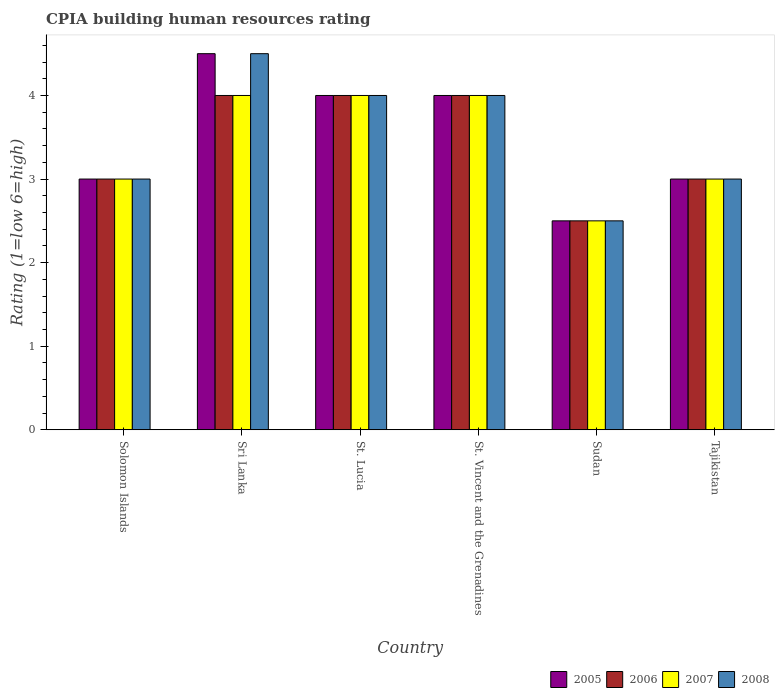How many different coloured bars are there?
Your answer should be very brief. 4. Are the number of bars per tick equal to the number of legend labels?
Make the answer very short. Yes. Are the number of bars on each tick of the X-axis equal?
Make the answer very short. Yes. How many bars are there on the 4th tick from the left?
Keep it short and to the point. 4. What is the label of the 2nd group of bars from the left?
Offer a very short reply. Sri Lanka. In which country was the CPIA rating in 2008 maximum?
Keep it short and to the point. Sri Lanka. In which country was the CPIA rating in 2006 minimum?
Offer a very short reply. Sudan. What is the average CPIA rating in 2008 per country?
Your answer should be very brief. 3.5. What is the difference between the CPIA rating of/in 2008 and CPIA rating of/in 2005 in Tajikistan?
Give a very brief answer. 0. In how many countries, is the CPIA rating in 2006 greater than 2.2?
Provide a succinct answer. 6. Is the difference between the CPIA rating in 2008 in Sudan and Tajikistan greater than the difference between the CPIA rating in 2005 in Sudan and Tajikistan?
Your response must be concise. No. What is the difference between the highest and the lowest CPIA rating in 2006?
Ensure brevity in your answer.  1.5. Is the sum of the CPIA rating in 2007 in St. Vincent and the Grenadines and Tajikistan greater than the maximum CPIA rating in 2008 across all countries?
Provide a short and direct response. Yes. What does the 2nd bar from the left in Solomon Islands represents?
Your response must be concise. 2006. What does the 2nd bar from the right in Sri Lanka represents?
Provide a short and direct response. 2007. How many bars are there?
Provide a succinct answer. 24. Are all the bars in the graph horizontal?
Provide a short and direct response. No. How many countries are there in the graph?
Offer a very short reply. 6. What is the difference between two consecutive major ticks on the Y-axis?
Ensure brevity in your answer.  1. Does the graph contain any zero values?
Give a very brief answer. No. Where does the legend appear in the graph?
Provide a succinct answer. Bottom right. How many legend labels are there?
Your answer should be very brief. 4. How are the legend labels stacked?
Your answer should be very brief. Horizontal. What is the title of the graph?
Provide a short and direct response. CPIA building human resources rating. What is the label or title of the Y-axis?
Your answer should be very brief. Rating (1=low 6=high). What is the Rating (1=low 6=high) of 2006 in Solomon Islands?
Your answer should be very brief. 3. What is the Rating (1=low 6=high) in 2005 in Sri Lanka?
Your response must be concise. 4.5. What is the Rating (1=low 6=high) of 2006 in Sri Lanka?
Make the answer very short. 4. What is the Rating (1=low 6=high) of 2008 in Sri Lanka?
Offer a very short reply. 4.5. What is the Rating (1=low 6=high) in 2005 in St. Lucia?
Your response must be concise. 4. What is the Rating (1=low 6=high) of 2006 in St. Lucia?
Keep it short and to the point. 4. What is the Rating (1=low 6=high) in 2008 in St. Lucia?
Ensure brevity in your answer.  4. What is the Rating (1=low 6=high) of 2006 in St. Vincent and the Grenadines?
Offer a terse response. 4. What is the Rating (1=low 6=high) of 2007 in St. Vincent and the Grenadines?
Your answer should be very brief. 4. What is the Rating (1=low 6=high) of 2008 in St. Vincent and the Grenadines?
Provide a short and direct response. 4. What is the Rating (1=low 6=high) in 2005 in Sudan?
Keep it short and to the point. 2.5. What is the Rating (1=low 6=high) of 2006 in Sudan?
Your answer should be compact. 2.5. What is the Rating (1=low 6=high) of 2007 in Sudan?
Offer a very short reply. 2.5. What is the Rating (1=low 6=high) of 2005 in Tajikistan?
Your response must be concise. 3. What is the Rating (1=low 6=high) in 2006 in Tajikistan?
Your answer should be compact. 3. What is the Rating (1=low 6=high) in 2007 in Tajikistan?
Provide a short and direct response. 3. Across all countries, what is the maximum Rating (1=low 6=high) in 2005?
Offer a very short reply. 4.5. Across all countries, what is the maximum Rating (1=low 6=high) of 2007?
Give a very brief answer. 4. Across all countries, what is the maximum Rating (1=low 6=high) of 2008?
Give a very brief answer. 4.5. Across all countries, what is the minimum Rating (1=low 6=high) of 2005?
Make the answer very short. 2.5. What is the total Rating (1=low 6=high) of 2005 in the graph?
Offer a very short reply. 21. What is the difference between the Rating (1=low 6=high) of 2006 in Solomon Islands and that in Sri Lanka?
Your answer should be very brief. -1. What is the difference between the Rating (1=low 6=high) of 2008 in Solomon Islands and that in Sri Lanka?
Offer a terse response. -1.5. What is the difference between the Rating (1=low 6=high) in 2005 in Solomon Islands and that in St. Lucia?
Offer a very short reply. -1. What is the difference between the Rating (1=low 6=high) in 2006 in Solomon Islands and that in St. Lucia?
Ensure brevity in your answer.  -1. What is the difference between the Rating (1=low 6=high) of 2007 in Solomon Islands and that in St. Lucia?
Your answer should be very brief. -1. What is the difference between the Rating (1=low 6=high) of 2008 in Solomon Islands and that in St. Vincent and the Grenadines?
Ensure brevity in your answer.  -1. What is the difference between the Rating (1=low 6=high) of 2007 in Solomon Islands and that in Sudan?
Keep it short and to the point. 0.5. What is the difference between the Rating (1=low 6=high) in 2006 in Sri Lanka and that in St. Lucia?
Your answer should be very brief. 0. What is the difference between the Rating (1=low 6=high) of 2007 in Sri Lanka and that in St. Lucia?
Your response must be concise. 0. What is the difference between the Rating (1=low 6=high) of 2008 in Sri Lanka and that in St. Lucia?
Ensure brevity in your answer.  0.5. What is the difference between the Rating (1=low 6=high) of 2005 in Sri Lanka and that in St. Vincent and the Grenadines?
Make the answer very short. 0.5. What is the difference between the Rating (1=low 6=high) of 2006 in Sri Lanka and that in St. Vincent and the Grenadines?
Your answer should be compact. 0. What is the difference between the Rating (1=low 6=high) in 2007 in Sri Lanka and that in St. Vincent and the Grenadines?
Your answer should be very brief. 0. What is the difference between the Rating (1=low 6=high) in 2008 in Sri Lanka and that in St. Vincent and the Grenadines?
Offer a very short reply. 0.5. What is the difference between the Rating (1=low 6=high) of 2006 in Sri Lanka and that in Tajikistan?
Give a very brief answer. 1. What is the difference between the Rating (1=low 6=high) of 2008 in Sri Lanka and that in Tajikistan?
Your answer should be compact. 1.5. What is the difference between the Rating (1=low 6=high) in 2006 in St. Lucia and that in St. Vincent and the Grenadines?
Your answer should be compact. 0. What is the difference between the Rating (1=low 6=high) of 2005 in St. Lucia and that in Sudan?
Your response must be concise. 1.5. What is the difference between the Rating (1=low 6=high) in 2005 in St. Lucia and that in Tajikistan?
Provide a succinct answer. 1. What is the difference between the Rating (1=low 6=high) of 2005 in St. Vincent and the Grenadines and that in Sudan?
Provide a succinct answer. 1.5. What is the difference between the Rating (1=low 6=high) in 2006 in St. Vincent and the Grenadines and that in Sudan?
Provide a short and direct response. 1.5. What is the difference between the Rating (1=low 6=high) in 2005 in St. Vincent and the Grenadines and that in Tajikistan?
Provide a succinct answer. 1. What is the difference between the Rating (1=low 6=high) in 2007 in St. Vincent and the Grenadines and that in Tajikistan?
Your answer should be very brief. 1. What is the difference between the Rating (1=low 6=high) of 2007 in Sudan and that in Tajikistan?
Make the answer very short. -0.5. What is the difference between the Rating (1=low 6=high) of 2005 in Solomon Islands and the Rating (1=low 6=high) of 2008 in Sri Lanka?
Give a very brief answer. -1.5. What is the difference between the Rating (1=low 6=high) in 2006 in Solomon Islands and the Rating (1=low 6=high) in 2008 in Sri Lanka?
Ensure brevity in your answer.  -1.5. What is the difference between the Rating (1=low 6=high) of 2006 in Solomon Islands and the Rating (1=low 6=high) of 2008 in St. Lucia?
Ensure brevity in your answer.  -1. What is the difference between the Rating (1=low 6=high) of 2007 in Solomon Islands and the Rating (1=low 6=high) of 2008 in St. Lucia?
Offer a very short reply. -1. What is the difference between the Rating (1=low 6=high) in 2005 in Solomon Islands and the Rating (1=low 6=high) in 2006 in St. Vincent and the Grenadines?
Make the answer very short. -1. What is the difference between the Rating (1=low 6=high) of 2006 in Solomon Islands and the Rating (1=low 6=high) of 2007 in St. Vincent and the Grenadines?
Your answer should be compact. -1. What is the difference between the Rating (1=low 6=high) in 2006 in Solomon Islands and the Rating (1=low 6=high) in 2008 in St. Vincent and the Grenadines?
Ensure brevity in your answer.  -1. What is the difference between the Rating (1=low 6=high) of 2007 in Solomon Islands and the Rating (1=low 6=high) of 2008 in St. Vincent and the Grenadines?
Ensure brevity in your answer.  -1. What is the difference between the Rating (1=low 6=high) of 2005 in Solomon Islands and the Rating (1=low 6=high) of 2006 in Sudan?
Keep it short and to the point. 0.5. What is the difference between the Rating (1=low 6=high) of 2005 in Solomon Islands and the Rating (1=low 6=high) of 2008 in Sudan?
Offer a terse response. 0.5. What is the difference between the Rating (1=low 6=high) in 2006 in Solomon Islands and the Rating (1=low 6=high) in 2007 in Sudan?
Provide a short and direct response. 0.5. What is the difference between the Rating (1=low 6=high) in 2006 in Solomon Islands and the Rating (1=low 6=high) in 2008 in Sudan?
Keep it short and to the point. 0.5. What is the difference between the Rating (1=low 6=high) in 2005 in Solomon Islands and the Rating (1=low 6=high) in 2007 in Tajikistan?
Your answer should be compact. 0. What is the difference between the Rating (1=low 6=high) of 2005 in Solomon Islands and the Rating (1=low 6=high) of 2008 in Tajikistan?
Provide a succinct answer. 0. What is the difference between the Rating (1=low 6=high) of 2006 in Solomon Islands and the Rating (1=low 6=high) of 2007 in Tajikistan?
Provide a succinct answer. 0. What is the difference between the Rating (1=low 6=high) of 2005 in Sri Lanka and the Rating (1=low 6=high) of 2006 in St. Lucia?
Ensure brevity in your answer.  0.5. What is the difference between the Rating (1=low 6=high) of 2005 in Sri Lanka and the Rating (1=low 6=high) of 2008 in St. Lucia?
Your answer should be compact. 0.5. What is the difference between the Rating (1=low 6=high) in 2005 in Sri Lanka and the Rating (1=low 6=high) in 2006 in St. Vincent and the Grenadines?
Offer a terse response. 0.5. What is the difference between the Rating (1=low 6=high) in 2005 in Sri Lanka and the Rating (1=low 6=high) in 2007 in St. Vincent and the Grenadines?
Give a very brief answer. 0.5. What is the difference between the Rating (1=low 6=high) of 2006 in Sri Lanka and the Rating (1=low 6=high) of 2008 in St. Vincent and the Grenadines?
Keep it short and to the point. 0. What is the difference between the Rating (1=low 6=high) of 2007 in Sri Lanka and the Rating (1=low 6=high) of 2008 in St. Vincent and the Grenadines?
Give a very brief answer. 0. What is the difference between the Rating (1=low 6=high) in 2005 in Sri Lanka and the Rating (1=low 6=high) in 2007 in Sudan?
Ensure brevity in your answer.  2. What is the difference between the Rating (1=low 6=high) of 2005 in Sri Lanka and the Rating (1=low 6=high) of 2008 in Sudan?
Your response must be concise. 2. What is the difference between the Rating (1=low 6=high) in 2006 in Sri Lanka and the Rating (1=low 6=high) in 2007 in Sudan?
Keep it short and to the point. 1.5. What is the difference between the Rating (1=low 6=high) of 2005 in Sri Lanka and the Rating (1=low 6=high) of 2007 in Tajikistan?
Make the answer very short. 1.5. What is the difference between the Rating (1=low 6=high) in 2006 in Sri Lanka and the Rating (1=low 6=high) in 2007 in Tajikistan?
Your response must be concise. 1. What is the difference between the Rating (1=low 6=high) of 2006 in Sri Lanka and the Rating (1=low 6=high) of 2008 in Tajikistan?
Make the answer very short. 1. What is the difference between the Rating (1=low 6=high) of 2007 in Sri Lanka and the Rating (1=low 6=high) of 2008 in Tajikistan?
Offer a very short reply. 1. What is the difference between the Rating (1=low 6=high) of 2005 in St. Lucia and the Rating (1=low 6=high) of 2006 in St. Vincent and the Grenadines?
Your answer should be compact. 0. What is the difference between the Rating (1=low 6=high) in 2005 in St. Lucia and the Rating (1=low 6=high) in 2008 in St. Vincent and the Grenadines?
Your answer should be very brief. 0. What is the difference between the Rating (1=low 6=high) in 2006 in St. Lucia and the Rating (1=low 6=high) in 2007 in St. Vincent and the Grenadines?
Keep it short and to the point. 0. What is the difference between the Rating (1=low 6=high) in 2006 in St. Lucia and the Rating (1=low 6=high) in 2008 in St. Vincent and the Grenadines?
Provide a short and direct response. 0. What is the difference between the Rating (1=low 6=high) of 2007 in St. Lucia and the Rating (1=low 6=high) of 2008 in St. Vincent and the Grenadines?
Your answer should be compact. 0. What is the difference between the Rating (1=low 6=high) in 2005 in St. Lucia and the Rating (1=low 6=high) in 2006 in Sudan?
Offer a terse response. 1.5. What is the difference between the Rating (1=low 6=high) of 2005 in St. Lucia and the Rating (1=low 6=high) of 2007 in Sudan?
Provide a short and direct response. 1.5. What is the difference between the Rating (1=low 6=high) of 2007 in St. Lucia and the Rating (1=low 6=high) of 2008 in Sudan?
Make the answer very short. 1.5. What is the difference between the Rating (1=low 6=high) in 2005 in St. Lucia and the Rating (1=low 6=high) in 2007 in Tajikistan?
Give a very brief answer. 1. What is the difference between the Rating (1=low 6=high) of 2006 in St. Lucia and the Rating (1=low 6=high) of 2008 in Tajikistan?
Keep it short and to the point. 1. What is the difference between the Rating (1=low 6=high) of 2005 in St. Vincent and the Grenadines and the Rating (1=low 6=high) of 2006 in Sudan?
Your answer should be very brief. 1.5. What is the difference between the Rating (1=low 6=high) of 2005 in St. Vincent and the Grenadines and the Rating (1=low 6=high) of 2008 in Sudan?
Offer a very short reply. 1.5. What is the difference between the Rating (1=low 6=high) in 2006 in St. Vincent and the Grenadines and the Rating (1=low 6=high) in 2007 in Sudan?
Your response must be concise. 1.5. What is the difference between the Rating (1=low 6=high) of 2005 in St. Vincent and the Grenadines and the Rating (1=low 6=high) of 2006 in Tajikistan?
Provide a short and direct response. 1. What is the difference between the Rating (1=low 6=high) in 2005 in St. Vincent and the Grenadines and the Rating (1=low 6=high) in 2008 in Tajikistan?
Offer a terse response. 1. What is the difference between the Rating (1=low 6=high) of 2006 in St. Vincent and the Grenadines and the Rating (1=low 6=high) of 2007 in Tajikistan?
Your response must be concise. 1. What is the difference between the Rating (1=low 6=high) of 2006 in Sudan and the Rating (1=low 6=high) of 2007 in Tajikistan?
Your response must be concise. -0.5. What is the difference between the Rating (1=low 6=high) of 2006 in Sudan and the Rating (1=low 6=high) of 2008 in Tajikistan?
Your response must be concise. -0.5. What is the average Rating (1=low 6=high) in 2005 per country?
Make the answer very short. 3.5. What is the average Rating (1=low 6=high) of 2006 per country?
Provide a succinct answer. 3.42. What is the average Rating (1=low 6=high) of 2007 per country?
Offer a very short reply. 3.42. What is the average Rating (1=low 6=high) in 2008 per country?
Offer a terse response. 3.5. What is the difference between the Rating (1=low 6=high) in 2005 and Rating (1=low 6=high) in 2006 in Solomon Islands?
Give a very brief answer. 0. What is the difference between the Rating (1=low 6=high) in 2005 and Rating (1=low 6=high) in 2007 in Solomon Islands?
Your answer should be very brief. 0. What is the difference between the Rating (1=low 6=high) of 2006 and Rating (1=low 6=high) of 2007 in Solomon Islands?
Offer a very short reply. 0. What is the difference between the Rating (1=low 6=high) in 2005 and Rating (1=low 6=high) in 2007 in Sri Lanka?
Ensure brevity in your answer.  0.5. What is the difference between the Rating (1=low 6=high) in 2005 and Rating (1=low 6=high) in 2008 in Sri Lanka?
Give a very brief answer. 0. What is the difference between the Rating (1=low 6=high) in 2007 and Rating (1=low 6=high) in 2008 in Sri Lanka?
Make the answer very short. -0.5. What is the difference between the Rating (1=low 6=high) of 2005 and Rating (1=low 6=high) of 2006 in St. Lucia?
Your response must be concise. 0. What is the difference between the Rating (1=low 6=high) in 2005 and Rating (1=low 6=high) in 2007 in St. Lucia?
Your answer should be very brief. 0. What is the difference between the Rating (1=low 6=high) of 2006 and Rating (1=low 6=high) of 2007 in St. Lucia?
Ensure brevity in your answer.  0. What is the difference between the Rating (1=low 6=high) in 2007 and Rating (1=low 6=high) in 2008 in St. Lucia?
Your answer should be compact. 0. What is the difference between the Rating (1=low 6=high) of 2005 and Rating (1=low 6=high) of 2006 in St. Vincent and the Grenadines?
Offer a terse response. 0. What is the difference between the Rating (1=low 6=high) of 2007 and Rating (1=low 6=high) of 2008 in St. Vincent and the Grenadines?
Your answer should be very brief. 0. What is the difference between the Rating (1=low 6=high) in 2005 and Rating (1=low 6=high) in 2007 in Sudan?
Offer a very short reply. 0. What is the difference between the Rating (1=low 6=high) of 2006 and Rating (1=low 6=high) of 2008 in Sudan?
Your response must be concise. 0. What is the difference between the Rating (1=low 6=high) in 2007 and Rating (1=low 6=high) in 2008 in Sudan?
Provide a short and direct response. 0. What is the difference between the Rating (1=low 6=high) in 2005 and Rating (1=low 6=high) in 2006 in Tajikistan?
Your response must be concise. 0. What is the difference between the Rating (1=low 6=high) in 2005 and Rating (1=low 6=high) in 2008 in Tajikistan?
Your answer should be compact. 0. What is the difference between the Rating (1=low 6=high) in 2006 and Rating (1=low 6=high) in 2007 in Tajikistan?
Your answer should be very brief. 0. What is the difference between the Rating (1=low 6=high) of 2007 and Rating (1=low 6=high) of 2008 in Tajikistan?
Offer a terse response. 0. What is the ratio of the Rating (1=low 6=high) of 2005 in Solomon Islands to that in Sri Lanka?
Provide a short and direct response. 0.67. What is the ratio of the Rating (1=low 6=high) of 2007 in Solomon Islands to that in Sri Lanka?
Make the answer very short. 0.75. What is the ratio of the Rating (1=low 6=high) in 2008 in Solomon Islands to that in Sri Lanka?
Offer a very short reply. 0.67. What is the ratio of the Rating (1=low 6=high) in 2006 in Solomon Islands to that in St. Lucia?
Provide a succinct answer. 0.75. What is the ratio of the Rating (1=low 6=high) of 2007 in Solomon Islands to that in St. Lucia?
Keep it short and to the point. 0.75. What is the ratio of the Rating (1=low 6=high) of 2005 in Solomon Islands to that in St. Vincent and the Grenadines?
Your answer should be very brief. 0.75. What is the ratio of the Rating (1=low 6=high) of 2008 in Solomon Islands to that in St. Vincent and the Grenadines?
Make the answer very short. 0.75. What is the ratio of the Rating (1=low 6=high) of 2007 in Solomon Islands to that in Sudan?
Your answer should be very brief. 1.2. What is the ratio of the Rating (1=low 6=high) in 2008 in Solomon Islands to that in Tajikistan?
Make the answer very short. 1. What is the ratio of the Rating (1=low 6=high) of 2005 in Sri Lanka to that in St. Lucia?
Make the answer very short. 1.12. What is the ratio of the Rating (1=low 6=high) of 2008 in Sri Lanka to that in St. Lucia?
Make the answer very short. 1.12. What is the ratio of the Rating (1=low 6=high) of 2005 in Sri Lanka to that in St. Vincent and the Grenadines?
Offer a very short reply. 1.12. What is the ratio of the Rating (1=low 6=high) of 2008 in Sri Lanka to that in St. Vincent and the Grenadines?
Offer a very short reply. 1.12. What is the ratio of the Rating (1=low 6=high) in 2007 in Sri Lanka to that in Sudan?
Provide a short and direct response. 1.6. What is the ratio of the Rating (1=low 6=high) in 2005 in Sri Lanka to that in Tajikistan?
Offer a very short reply. 1.5. What is the ratio of the Rating (1=low 6=high) in 2007 in Sri Lanka to that in Tajikistan?
Provide a short and direct response. 1.33. What is the ratio of the Rating (1=low 6=high) in 2007 in St. Lucia to that in St. Vincent and the Grenadines?
Provide a short and direct response. 1. What is the ratio of the Rating (1=low 6=high) of 2008 in St. Lucia to that in St. Vincent and the Grenadines?
Make the answer very short. 1. What is the ratio of the Rating (1=low 6=high) of 2007 in St. Lucia to that in Sudan?
Make the answer very short. 1.6. What is the ratio of the Rating (1=low 6=high) of 2008 in St. Lucia to that in Sudan?
Provide a short and direct response. 1.6. What is the ratio of the Rating (1=low 6=high) in 2005 in St. Lucia to that in Tajikistan?
Your answer should be very brief. 1.33. What is the ratio of the Rating (1=low 6=high) in 2006 in St. Lucia to that in Tajikistan?
Provide a short and direct response. 1.33. What is the ratio of the Rating (1=low 6=high) in 2007 in St. Lucia to that in Tajikistan?
Give a very brief answer. 1.33. What is the ratio of the Rating (1=low 6=high) in 2008 in St. Lucia to that in Tajikistan?
Your answer should be compact. 1.33. What is the ratio of the Rating (1=low 6=high) in 2006 in St. Vincent and the Grenadines to that in Sudan?
Make the answer very short. 1.6. What is the ratio of the Rating (1=low 6=high) of 2008 in St. Vincent and the Grenadines to that in Sudan?
Give a very brief answer. 1.6. What is the ratio of the Rating (1=low 6=high) in 2007 in St. Vincent and the Grenadines to that in Tajikistan?
Offer a terse response. 1.33. What is the ratio of the Rating (1=low 6=high) of 2008 in St. Vincent and the Grenadines to that in Tajikistan?
Your response must be concise. 1.33. What is the ratio of the Rating (1=low 6=high) in 2007 in Sudan to that in Tajikistan?
Keep it short and to the point. 0.83. 